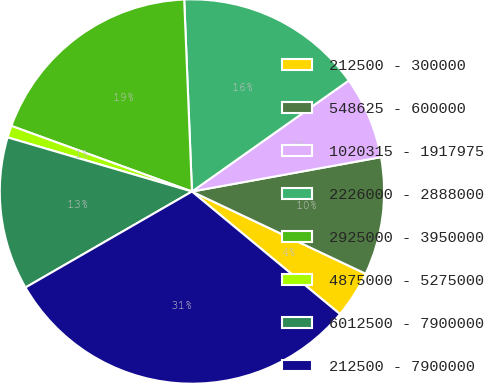Convert chart to OTSL. <chart><loc_0><loc_0><loc_500><loc_500><pie_chart><fcel>212500 - 300000<fcel>548625 - 600000<fcel>1020315 - 1917975<fcel>2226000 - 2888000<fcel>2925000 - 3950000<fcel>4875000 - 5275000<fcel>6012500 - 7900000<fcel>212500 - 7900000<nl><fcel>3.97%<fcel>9.9%<fcel>6.94%<fcel>15.84%<fcel>18.81%<fcel>1.0%<fcel>12.87%<fcel>30.67%<nl></chart> 